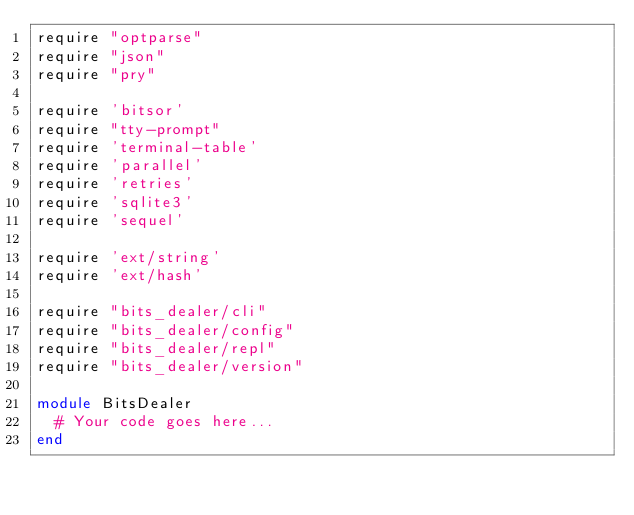Convert code to text. <code><loc_0><loc_0><loc_500><loc_500><_Ruby_>require "optparse"
require "json"
require "pry"

require 'bitsor'
require "tty-prompt"
require 'terminal-table'
require 'parallel'
require 'retries'
require 'sqlite3'
require 'sequel'

require 'ext/string'
require 'ext/hash'

require "bits_dealer/cli"
require "bits_dealer/config"
require "bits_dealer/repl"
require "bits_dealer/version"

module BitsDealer
  # Your code goes here...
end
</code> 